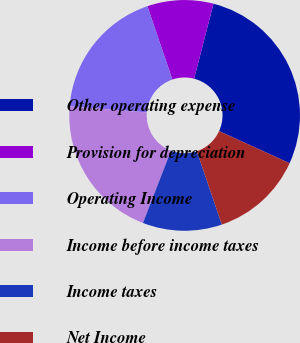Convert chart. <chart><loc_0><loc_0><loc_500><loc_500><pie_chart><fcel>Other operating expense<fcel>Provision for depreciation<fcel>Operating Income<fcel>Income before income taxes<fcel>Income taxes<fcel>Net Income<nl><fcel>27.78%<fcel>9.26%<fcel>18.52%<fcel>20.37%<fcel>11.11%<fcel>12.96%<nl></chart> 